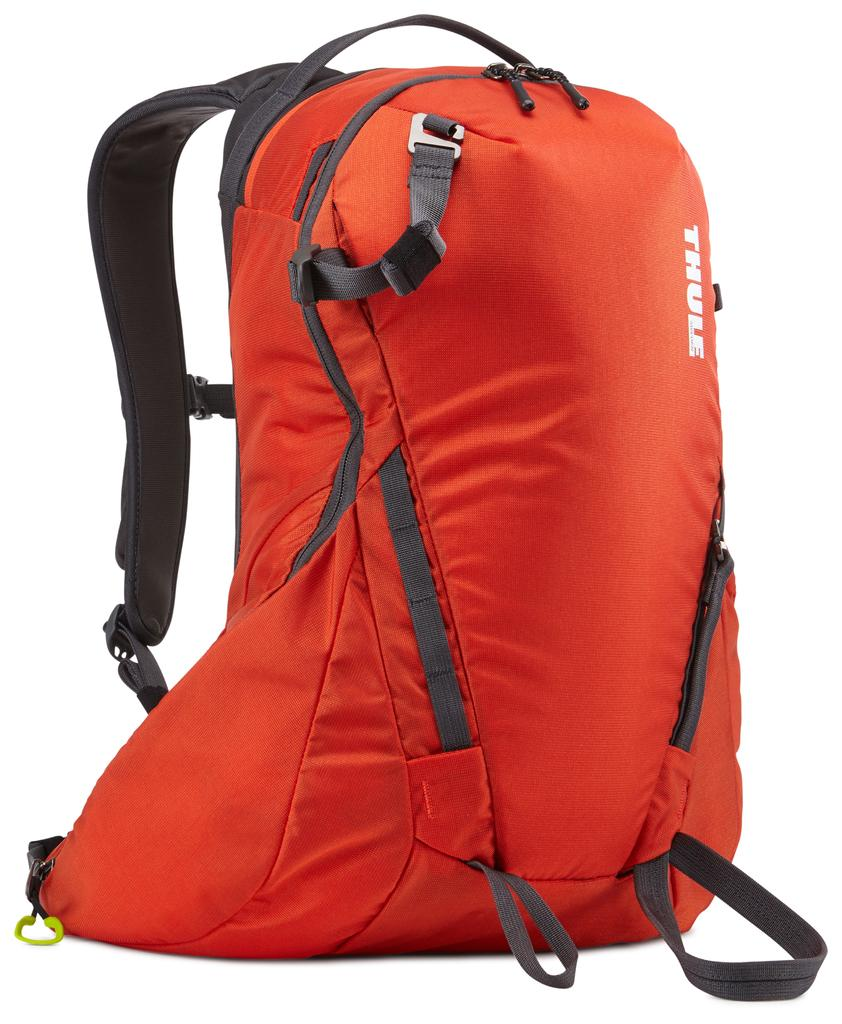What type of object is visible in the image? There is a travel bag in the image. What color is the travel bag? The travel bag is orange in color. What can be seen in the background of the image? The background of the image is white. How many beds are visible in the image? There are no beds present in the image; it features a travel bag. What type of twig can be seen in the image? There is no twig present in the image. 